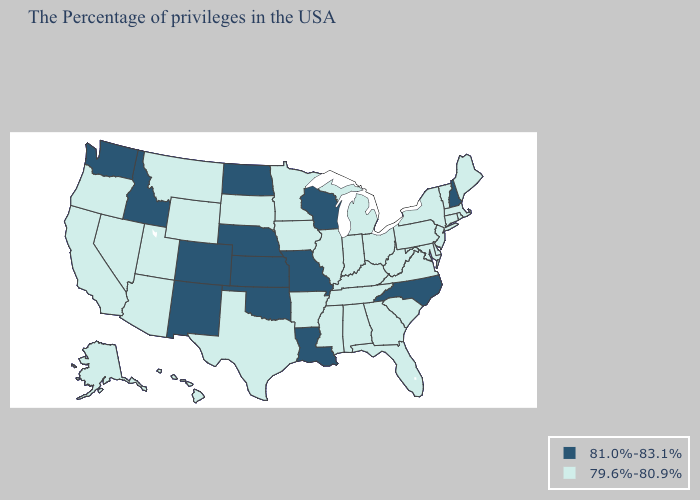Does Missouri have the lowest value in the USA?
Answer briefly. No. Does Florida have the lowest value in the USA?
Quick response, please. Yes. What is the lowest value in states that border Massachusetts?
Keep it brief. 79.6%-80.9%. Among the states that border Delaware , which have the highest value?
Quick response, please. New Jersey, Maryland, Pennsylvania. Does Maryland have the same value as North Carolina?
Quick response, please. No. Name the states that have a value in the range 81.0%-83.1%?
Quick response, please. New Hampshire, North Carolina, Wisconsin, Louisiana, Missouri, Kansas, Nebraska, Oklahoma, North Dakota, Colorado, New Mexico, Idaho, Washington. What is the lowest value in the USA?
Keep it brief. 79.6%-80.9%. Name the states that have a value in the range 81.0%-83.1%?
Answer briefly. New Hampshire, North Carolina, Wisconsin, Louisiana, Missouri, Kansas, Nebraska, Oklahoma, North Dakota, Colorado, New Mexico, Idaho, Washington. Which states have the lowest value in the MidWest?
Give a very brief answer. Ohio, Michigan, Indiana, Illinois, Minnesota, Iowa, South Dakota. Which states have the highest value in the USA?
Give a very brief answer. New Hampshire, North Carolina, Wisconsin, Louisiana, Missouri, Kansas, Nebraska, Oklahoma, North Dakota, Colorado, New Mexico, Idaho, Washington. Does Arizona have the lowest value in the USA?
Concise answer only. Yes. Name the states that have a value in the range 79.6%-80.9%?
Give a very brief answer. Maine, Massachusetts, Rhode Island, Vermont, Connecticut, New York, New Jersey, Delaware, Maryland, Pennsylvania, Virginia, South Carolina, West Virginia, Ohio, Florida, Georgia, Michigan, Kentucky, Indiana, Alabama, Tennessee, Illinois, Mississippi, Arkansas, Minnesota, Iowa, Texas, South Dakota, Wyoming, Utah, Montana, Arizona, Nevada, California, Oregon, Alaska, Hawaii. Among the states that border Utah , does Colorado have the highest value?
Give a very brief answer. Yes. Which states have the lowest value in the West?
Give a very brief answer. Wyoming, Utah, Montana, Arizona, Nevada, California, Oregon, Alaska, Hawaii. 